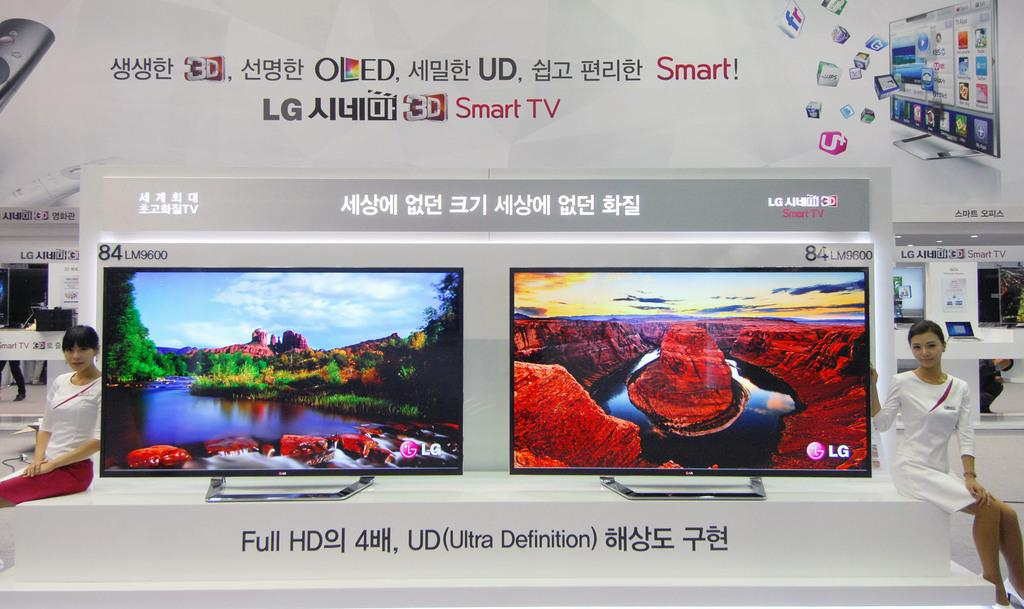<image>
Relay a brief, clear account of the picture shown. two women models by Smart TV screens that say Smart! LG Smart TV Full HD, UD (Ultra Definition).. 